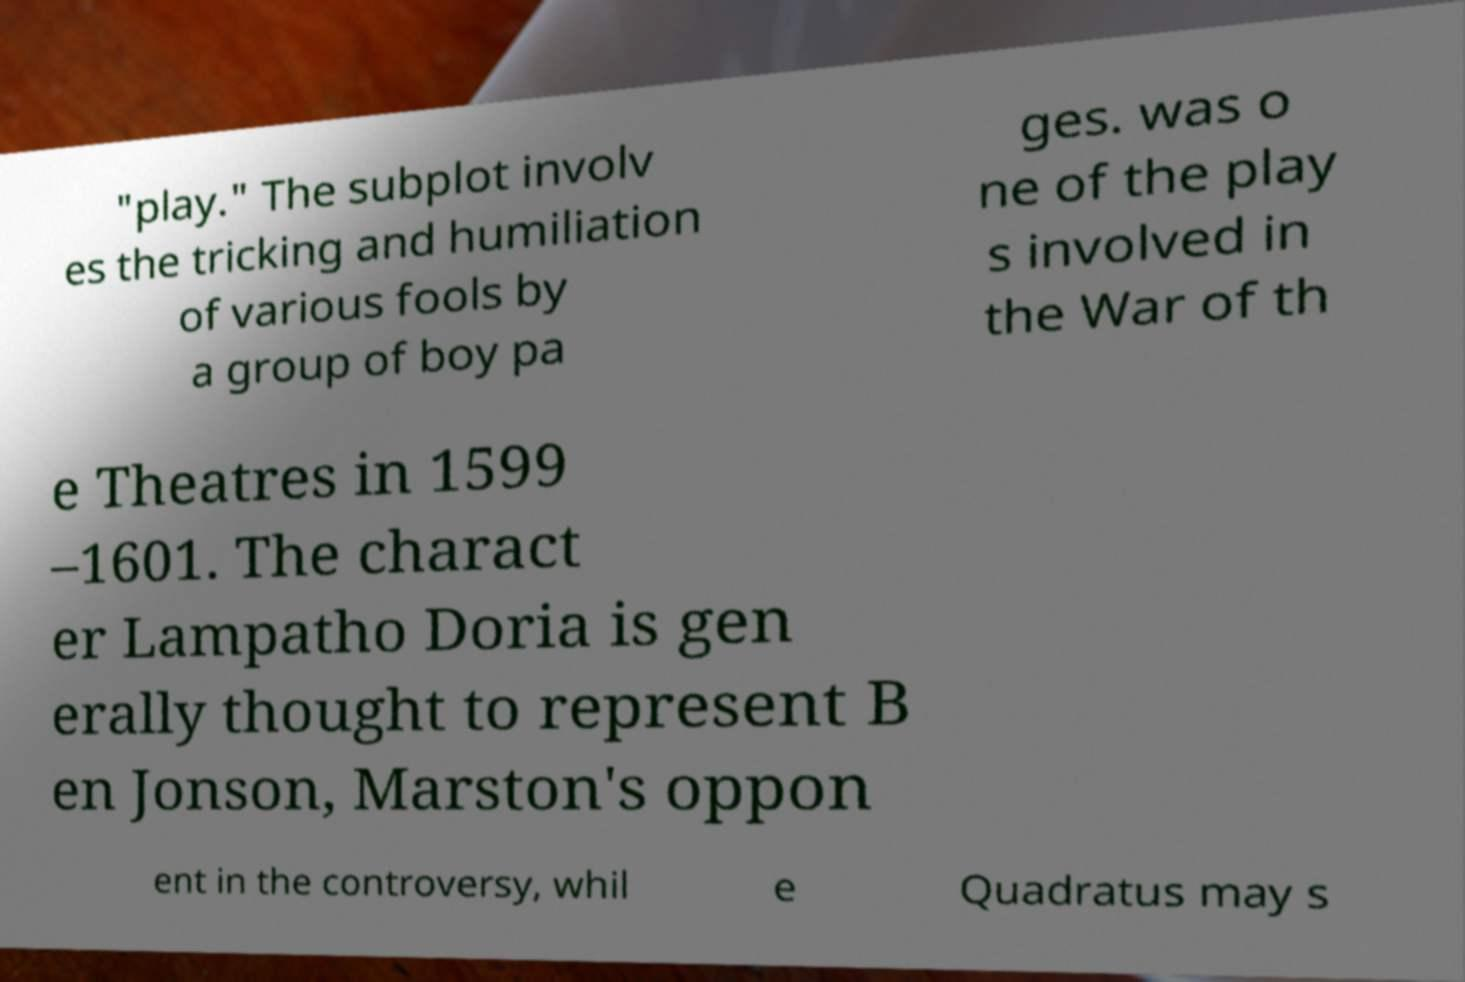I need the written content from this picture converted into text. Can you do that? "play." The subplot involv es the tricking and humiliation of various fools by a group of boy pa ges. was o ne of the play s involved in the War of th e Theatres in 1599 –1601. The charact er Lampatho Doria is gen erally thought to represent B en Jonson, Marston's oppon ent in the controversy, whil e Quadratus may s 